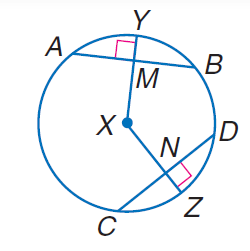Answer the mathemtical geometry problem and directly provide the correct option letter.
Question: In \odot X, A B = 30, C D = 30, and m \widehat C Z = 40. Find M B.
Choices: A: 10 B: 15 C: 20 D: 30 B 